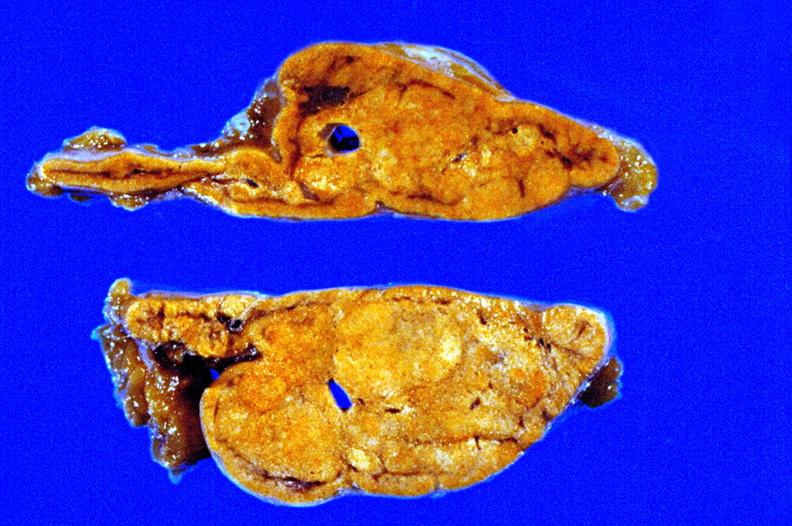how is fixed tissue cut surface close-up view rather apparently non-functional?
Answer the question using a single word or phrase. Good 